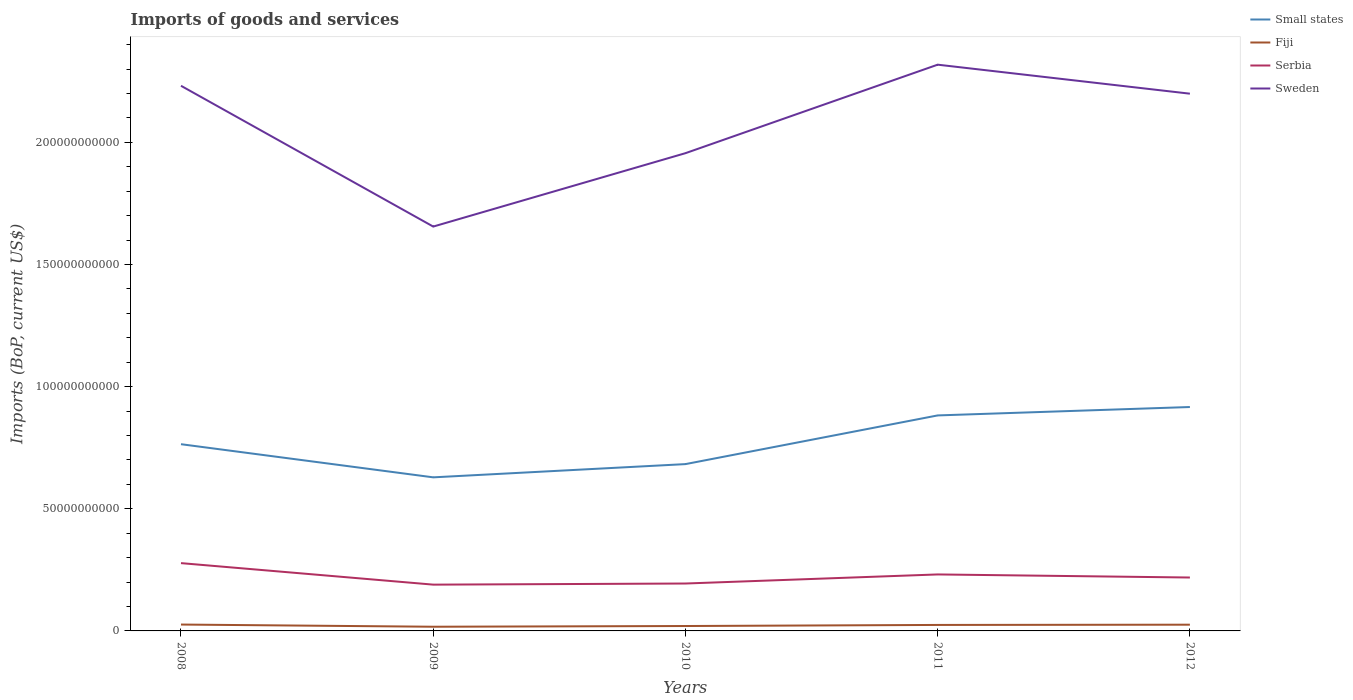How many different coloured lines are there?
Provide a short and direct response. 4. Is the number of lines equal to the number of legend labels?
Your answer should be very brief. Yes. Across all years, what is the maximum amount spent on imports in Sweden?
Make the answer very short. 1.66e+11. What is the total amount spent on imports in Serbia in the graph?
Offer a terse response. -2.46e+09. What is the difference between the highest and the second highest amount spent on imports in Sweden?
Your answer should be compact. 6.63e+1. Is the amount spent on imports in Serbia strictly greater than the amount spent on imports in Small states over the years?
Provide a succinct answer. Yes. How many years are there in the graph?
Keep it short and to the point. 5. What is the difference between two consecutive major ticks on the Y-axis?
Offer a very short reply. 5.00e+1. Are the values on the major ticks of Y-axis written in scientific E-notation?
Make the answer very short. No. Does the graph contain any zero values?
Provide a short and direct response. No. Where does the legend appear in the graph?
Provide a succinct answer. Top right. What is the title of the graph?
Your response must be concise. Imports of goods and services. Does "Lebanon" appear as one of the legend labels in the graph?
Give a very brief answer. No. What is the label or title of the X-axis?
Your answer should be very brief. Years. What is the label or title of the Y-axis?
Your answer should be compact. Imports (BoP, current US$). What is the Imports (BoP, current US$) in Small states in 2008?
Provide a short and direct response. 7.64e+1. What is the Imports (BoP, current US$) in Fiji in 2008?
Give a very brief answer. 2.61e+09. What is the Imports (BoP, current US$) in Serbia in 2008?
Provide a succinct answer. 2.78e+1. What is the Imports (BoP, current US$) of Sweden in 2008?
Keep it short and to the point. 2.23e+11. What is the Imports (BoP, current US$) of Small states in 2009?
Provide a succinct answer. 6.29e+1. What is the Imports (BoP, current US$) of Fiji in 2009?
Give a very brief answer. 1.71e+09. What is the Imports (BoP, current US$) in Serbia in 2009?
Keep it short and to the point. 1.89e+1. What is the Imports (BoP, current US$) of Sweden in 2009?
Offer a terse response. 1.66e+11. What is the Imports (BoP, current US$) of Small states in 2010?
Your answer should be compact. 6.83e+1. What is the Imports (BoP, current US$) in Fiji in 2010?
Keep it short and to the point. 2.01e+09. What is the Imports (BoP, current US$) in Serbia in 2010?
Your answer should be compact. 1.94e+1. What is the Imports (BoP, current US$) in Sweden in 2010?
Your answer should be compact. 1.96e+11. What is the Imports (BoP, current US$) of Small states in 2011?
Offer a very short reply. 8.82e+1. What is the Imports (BoP, current US$) in Fiji in 2011?
Offer a terse response. 2.45e+09. What is the Imports (BoP, current US$) in Serbia in 2011?
Offer a very short reply. 2.31e+1. What is the Imports (BoP, current US$) of Sweden in 2011?
Provide a short and direct response. 2.32e+11. What is the Imports (BoP, current US$) of Small states in 2012?
Your response must be concise. 9.17e+1. What is the Imports (BoP, current US$) in Fiji in 2012?
Provide a succinct answer. 2.55e+09. What is the Imports (BoP, current US$) in Serbia in 2012?
Your answer should be compact. 2.19e+1. What is the Imports (BoP, current US$) in Sweden in 2012?
Your answer should be compact. 2.20e+11. Across all years, what is the maximum Imports (BoP, current US$) of Small states?
Your response must be concise. 9.17e+1. Across all years, what is the maximum Imports (BoP, current US$) of Fiji?
Make the answer very short. 2.61e+09. Across all years, what is the maximum Imports (BoP, current US$) of Serbia?
Offer a very short reply. 2.78e+1. Across all years, what is the maximum Imports (BoP, current US$) in Sweden?
Give a very brief answer. 2.32e+11. Across all years, what is the minimum Imports (BoP, current US$) in Small states?
Keep it short and to the point. 6.29e+1. Across all years, what is the minimum Imports (BoP, current US$) of Fiji?
Your answer should be compact. 1.71e+09. Across all years, what is the minimum Imports (BoP, current US$) of Serbia?
Provide a succinct answer. 1.89e+1. Across all years, what is the minimum Imports (BoP, current US$) in Sweden?
Your answer should be very brief. 1.66e+11. What is the total Imports (BoP, current US$) of Small states in the graph?
Provide a succinct answer. 3.87e+11. What is the total Imports (BoP, current US$) in Fiji in the graph?
Give a very brief answer. 1.13e+1. What is the total Imports (BoP, current US$) of Serbia in the graph?
Ensure brevity in your answer.  1.11e+11. What is the total Imports (BoP, current US$) of Sweden in the graph?
Offer a terse response. 1.04e+12. What is the difference between the Imports (BoP, current US$) of Small states in 2008 and that in 2009?
Your response must be concise. 1.36e+1. What is the difference between the Imports (BoP, current US$) in Fiji in 2008 and that in 2009?
Provide a short and direct response. 8.98e+08. What is the difference between the Imports (BoP, current US$) of Serbia in 2008 and that in 2009?
Your answer should be very brief. 8.80e+09. What is the difference between the Imports (BoP, current US$) of Sweden in 2008 and that in 2009?
Offer a very short reply. 5.76e+1. What is the difference between the Imports (BoP, current US$) of Small states in 2008 and that in 2010?
Offer a terse response. 8.15e+09. What is the difference between the Imports (BoP, current US$) of Fiji in 2008 and that in 2010?
Offer a very short reply. 6.00e+08. What is the difference between the Imports (BoP, current US$) of Serbia in 2008 and that in 2010?
Provide a succinct answer. 8.35e+09. What is the difference between the Imports (BoP, current US$) of Sweden in 2008 and that in 2010?
Offer a terse response. 2.76e+1. What is the difference between the Imports (BoP, current US$) of Small states in 2008 and that in 2011?
Ensure brevity in your answer.  -1.18e+1. What is the difference between the Imports (BoP, current US$) in Fiji in 2008 and that in 2011?
Provide a short and direct response. 1.58e+08. What is the difference between the Imports (BoP, current US$) in Serbia in 2008 and that in 2011?
Provide a short and direct response. 4.63e+09. What is the difference between the Imports (BoP, current US$) of Sweden in 2008 and that in 2011?
Make the answer very short. -8.64e+09. What is the difference between the Imports (BoP, current US$) of Small states in 2008 and that in 2012?
Offer a terse response. -1.52e+1. What is the difference between the Imports (BoP, current US$) in Fiji in 2008 and that in 2012?
Ensure brevity in your answer.  5.92e+07. What is the difference between the Imports (BoP, current US$) in Serbia in 2008 and that in 2012?
Keep it short and to the point. 5.89e+09. What is the difference between the Imports (BoP, current US$) in Sweden in 2008 and that in 2012?
Make the answer very short. 3.24e+09. What is the difference between the Imports (BoP, current US$) of Small states in 2009 and that in 2010?
Give a very brief answer. -5.42e+09. What is the difference between the Imports (BoP, current US$) of Fiji in 2009 and that in 2010?
Offer a terse response. -2.98e+08. What is the difference between the Imports (BoP, current US$) of Serbia in 2009 and that in 2010?
Offer a very short reply. -4.57e+08. What is the difference between the Imports (BoP, current US$) of Sweden in 2009 and that in 2010?
Give a very brief answer. -3.00e+1. What is the difference between the Imports (BoP, current US$) of Small states in 2009 and that in 2011?
Your response must be concise. -2.53e+1. What is the difference between the Imports (BoP, current US$) in Fiji in 2009 and that in 2011?
Ensure brevity in your answer.  -7.40e+08. What is the difference between the Imports (BoP, current US$) in Serbia in 2009 and that in 2011?
Give a very brief answer. -4.17e+09. What is the difference between the Imports (BoP, current US$) in Sweden in 2009 and that in 2011?
Your response must be concise. -6.63e+1. What is the difference between the Imports (BoP, current US$) in Small states in 2009 and that in 2012?
Your answer should be compact. -2.88e+1. What is the difference between the Imports (BoP, current US$) in Fiji in 2009 and that in 2012?
Keep it short and to the point. -8.39e+08. What is the difference between the Imports (BoP, current US$) of Serbia in 2009 and that in 2012?
Give a very brief answer. -2.91e+09. What is the difference between the Imports (BoP, current US$) of Sweden in 2009 and that in 2012?
Ensure brevity in your answer.  -5.44e+1. What is the difference between the Imports (BoP, current US$) of Small states in 2010 and that in 2011?
Ensure brevity in your answer.  -1.99e+1. What is the difference between the Imports (BoP, current US$) in Fiji in 2010 and that in 2011?
Keep it short and to the point. -4.42e+08. What is the difference between the Imports (BoP, current US$) of Serbia in 2010 and that in 2011?
Your answer should be compact. -3.71e+09. What is the difference between the Imports (BoP, current US$) in Sweden in 2010 and that in 2011?
Offer a very short reply. -3.62e+1. What is the difference between the Imports (BoP, current US$) of Small states in 2010 and that in 2012?
Provide a short and direct response. -2.34e+1. What is the difference between the Imports (BoP, current US$) of Fiji in 2010 and that in 2012?
Your response must be concise. -5.41e+08. What is the difference between the Imports (BoP, current US$) of Serbia in 2010 and that in 2012?
Your answer should be compact. -2.46e+09. What is the difference between the Imports (BoP, current US$) of Sweden in 2010 and that in 2012?
Ensure brevity in your answer.  -2.44e+1. What is the difference between the Imports (BoP, current US$) of Small states in 2011 and that in 2012?
Provide a succinct answer. -3.44e+09. What is the difference between the Imports (BoP, current US$) of Fiji in 2011 and that in 2012?
Offer a very short reply. -9.92e+07. What is the difference between the Imports (BoP, current US$) of Serbia in 2011 and that in 2012?
Make the answer very short. 1.26e+09. What is the difference between the Imports (BoP, current US$) in Sweden in 2011 and that in 2012?
Give a very brief answer. 1.19e+1. What is the difference between the Imports (BoP, current US$) of Small states in 2008 and the Imports (BoP, current US$) of Fiji in 2009?
Your answer should be very brief. 7.47e+1. What is the difference between the Imports (BoP, current US$) of Small states in 2008 and the Imports (BoP, current US$) of Serbia in 2009?
Your answer should be very brief. 5.75e+1. What is the difference between the Imports (BoP, current US$) in Small states in 2008 and the Imports (BoP, current US$) in Sweden in 2009?
Your response must be concise. -8.91e+1. What is the difference between the Imports (BoP, current US$) in Fiji in 2008 and the Imports (BoP, current US$) in Serbia in 2009?
Provide a short and direct response. -1.63e+1. What is the difference between the Imports (BoP, current US$) in Fiji in 2008 and the Imports (BoP, current US$) in Sweden in 2009?
Ensure brevity in your answer.  -1.63e+11. What is the difference between the Imports (BoP, current US$) in Serbia in 2008 and the Imports (BoP, current US$) in Sweden in 2009?
Your answer should be compact. -1.38e+11. What is the difference between the Imports (BoP, current US$) in Small states in 2008 and the Imports (BoP, current US$) in Fiji in 2010?
Your answer should be compact. 7.44e+1. What is the difference between the Imports (BoP, current US$) in Small states in 2008 and the Imports (BoP, current US$) in Serbia in 2010?
Your answer should be very brief. 5.70e+1. What is the difference between the Imports (BoP, current US$) of Small states in 2008 and the Imports (BoP, current US$) of Sweden in 2010?
Provide a succinct answer. -1.19e+11. What is the difference between the Imports (BoP, current US$) in Fiji in 2008 and the Imports (BoP, current US$) in Serbia in 2010?
Provide a succinct answer. -1.68e+1. What is the difference between the Imports (BoP, current US$) of Fiji in 2008 and the Imports (BoP, current US$) of Sweden in 2010?
Your answer should be compact. -1.93e+11. What is the difference between the Imports (BoP, current US$) in Serbia in 2008 and the Imports (BoP, current US$) in Sweden in 2010?
Offer a terse response. -1.68e+11. What is the difference between the Imports (BoP, current US$) in Small states in 2008 and the Imports (BoP, current US$) in Fiji in 2011?
Provide a short and direct response. 7.40e+1. What is the difference between the Imports (BoP, current US$) in Small states in 2008 and the Imports (BoP, current US$) in Serbia in 2011?
Ensure brevity in your answer.  5.33e+1. What is the difference between the Imports (BoP, current US$) of Small states in 2008 and the Imports (BoP, current US$) of Sweden in 2011?
Offer a very short reply. -1.55e+11. What is the difference between the Imports (BoP, current US$) in Fiji in 2008 and the Imports (BoP, current US$) in Serbia in 2011?
Offer a terse response. -2.05e+1. What is the difference between the Imports (BoP, current US$) in Fiji in 2008 and the Imports (BoP, current US$) in Sweden in 2011?
Ensure brevity in your answer.  -2.29e+11. What is the difference between the Imports (BoP, current US$) in Serbia in 2008 and the Imports (BoP, current US$) in Sweden in 2011?
Keep it short and to the point. -2.04e+11. What is the difference between the Imports (BoP, current US$) in Small states in 2008 and the Imports (BoP, current US$) in Fiji in 2012?
Offer a very short reply. 7.39e+1. What is the difference between the Imports (BoP, current US$) of Small states in 2008 and the Imports (BoP, current US$) of Serbia in 2012?
Your answer should be very brief. 5.46e+1. What is the difference between the Imports (BoP, current US$) of Small states in 2008 and the Imports (BoP, current US$) of Sweden in 2012?
Offer a terse response. -1.43e+11. What is the difference between the Imports (BoP, current US$) in Fiji in 2008 and the Imports (BoP, current US$) in Serbia in 2012?
Offer a terse response. -1.93e+1. What is the difference between the Imports (BoP, current US$) of Fiji in 2008 and the Imports (BoP, current US$) of Sweden in 2012?
Provide a short and direct response. -2.17e+11. What is the difference between the Imports (BoP, current US$) of Serbia in 2008 and the Imports (BoP, current US$) of Sweden in 2012?
Give a very brief answer. -1.92e+11. What is the difference between the Imports (BoP, current US$) in Small states in 2009 and the Imports (BoP, current US$) in Fiji in 2010?
Offer a terse response. 6.09e+1. What is the difference between the Imports (BoP, current US$) of Small states in 2009 and the Imports (BoP, current US$) of Serbia in 2010?
Make the answer very short. 4.35e+1. What is the difference between the Imports (BoP, current US$) of Small states in 2009 and the Imports (BoP, current US$) of Sweden in 2010?
Offer a very short reply. -1.33e+11. What is the difference between the Imports (BoP, current US$) in Fiji in 2009 and the Imports (BoP, current US$) in Serbia in 2010?
Your response must be concise. -1.77e+1. What is the difference between the Imports (BoP, current US$) in Fiji in 2009 and the Imports (BoP, current US$) in Sweden in 2010?
Keep it short and to the point. -1.94e+11. What is the difference between the Imports (BoP, current US$) in Serbia in 2009 and the Imports (BoP, current US$) in Sweden in 2010?
Keep it short and to the point. -1.77e+11. What is the difference between the Imports (BoP, current US$) in Small states in 2009 and the Imports (BoP, current US$) in Fiji in 2011?
Offer a very short reply. 6.04e+1. What is the difference between the Imports (BoP, current US$) in Small states in 2009 and the Imports (BoP, current US$) in Serbia in 2011?
Ensure brevity in your answer.  3.97e+1. What is the difference between the Imports (BoP, current US$) of Small states in 2009 and the Imports (BoP, current US$) of Sweden in 2011?
Keep it short and to the point. -1.69e+11. What is the difference between the Imports (BoP, current US$) of Fiji in 2009 and the Imports (BoP, current US$) of Serbia in 2011?
Give a very brief answer. -2.14e+1. What is the difference between the Imports (BoP, current US$) of Fiji in 2009 and the Imports (BoP, current US$) of Sweden in 2011?
Your response must be concise. -2.30e+11. What is the difference between the Imports (BoP, current US$) of Serbia in 2009 and the Imports (BoP, current US$) of Sweden in 2011?
Make the answer very short. -2.13e+11. What is the difference between the Imports (BoP, current US$) of Small states in 2009 and the Imports (BoP, current US$) of Fiji in 2012?
Offer a very short reply. 6.03e+1. What is the difference between the Imports (BoP, current US$) of Small states in 2009 and the Imports (BoP, current US$) of Serbia in 2012?
Your response must be concise. 4.10e+1. What is the difference between the Imports (BoP, current US$) of Small states in 2009 and the Imports (BoP, current US$) of Sweden in 2012?
Your answer should be compact. -1.57e+11. What is the difference between the Imports (BoP, current US$) in Fiji in 2009 and the Imports (BoP, current US$) in Serbia in 2012?
Keep it short and to the point. -2.01e+1. What is the difference between the Imports (BoP, current US$) in Fiji in 2009 and the Imports (BoP, current US$) in Sweden in 2012?
Make the answer very short. -2.18e+11. What is the difference between the Imports (BoP, current US$) of Serbia in 2009 and the Imports (BoP, current US$) of Sweden in 2012?
Provide a succinct answer. -2.01e+11. What is the difference between the Imports (BoP, current US$) in Small states in 2010 and the Imports (BoP, current US$) in Fiji in 2011?
Make the answer very short. 6.58e+1. What is the difference between the Imports (BoP, current US$) in Small states in 2010 and the Imports (BoP, current US$) in Serbia in 2011?
Offer a very short reply. 4.52e+1. What is the difference between the Imports (BoP, current US$) of Small states in 2010 and the Imports (BoP, current US$) of Sweden in 2011?
Make the answer very short. -1.64e+11. What is the difference between the Imports (BoP, current US$) of Fiji in 2010 and the Imports (BoP, current US$) of Serbia in 2011?
Provide a succinct answer. -2.11e+1. What is the difference between the Imports (BoP, current US$) of Fiji in 2010 and the Imports (BoP, current US$) of Sweden in 2011?
Keep it short and to the point. -2.30e+11. What is the difference between the Imports (BoP, current US$) of Serbia in 2010 and the Imports (BoP, current US$) of Sweden in 2011?
Your answer should be very brief. -2.12e+11. What is the difference between the Imports (BoP, current US$) in Small states in 2010 and the Imports (BoP, current US$) in Fiji in 2012?
Offer a terse response. 6.57e+1. What is the difference between the Imports (BoP, current US$) of Small states in 2010 and the Imports (BoP, current US$) of Serbia in 2012?
Offer a very short reply. 4.64e+1. What is the difference between the Imports (BoP, current US$) in Small states in 2010 and the Imports (BoP, current US$) in Sweden in 2012?
Provide a succinct answer. -1.52e+11. What is the difference between the Imports (BoP, current US$) in Fiji in 2010 and the Imports (BoP, current US$) in Serbia in 2012?
Keep it short and to the point. -1.99e+1. What is the difference between the Imports (BoP, current US$) of Fiji in 2010 and the Imports (BoP, current US$) of Sweden in 2012?
Your answer should be compact. -2.18e+11. What is the difference between the Imports (BoP, current US$) in Serbia in 2010 and the Imports (BoP, current US$) in Sweden in 2012?
Ensure brevity in your answer.  -2.01e+11. What is the difference between the Imports (BoP, current US$) in Small states in 2011 and the Imports (BoP, current US$) in Fiji in 2012?
Your response must be concise. 8.57e+1. What is the difference between the Imports (BoP, current US$) of Small states in 2011 and the Imports (BoP, current US$) of Serbia in 2012?
Give a very brief answer. 6.64e+1. What is the difference between the Imports (BoP, current US$) of Small states in 2011 and the Imports (BoP, current US$) of Sweden in 2012?
Keep it short and to the point. -1.32e+11. What is the difference between the Imports (BoP, current US$) in Fiji in 2011 and the Imports (BoP, current US$) in Serbia in 2012?
Keep it short and to the point. -1.94e+1. What is the difference between the Imports (BoP, current US$) in Fiji in 2011 and the Imports (BoP, current US$) in Sweden in 2012?
Provide a succinct answer. -2.17e+11. What is the difference between the Imports (BoP, current US$) of Serbia in 2011 and the Imports (BoP, current US$) of Sweden in 2012?
Keep it short and to the point. -1.97e+11. What is the average Imports (BoP, current US$) of Small states per year?
Your response must be concise. 7.75e+1. What is the average Imports (BoP, current US$) in Fiji per year?
Your answer should be compact. 2.27e+09. What is the average Imports (BoP, current US$) of Serbia per year?
Provide a short and direct response. 2.22e+1. What is the average Imports (BoP, current US$) in Sweden per year?
Provide a short and direct response. 2.07e+11. In the year 2008, what is the difference between the Imports (BoP, current US$) in Small states and Imports (BoP, current US$) in Fiji?
Give a very brief answer. 7.38e+1. In the year 2008, what is the difference between the Imports (BoP, current US$) of Small states and Imports (BoP, current US$) of Serbia?
Make the answer very short. 4.87e+1. In the year 2008, what is the difference between the Imports (BoP, current US$) of Small states and Imports (BoP, current US$) of Sweden?
Your answer should be compact. -1.47e+11. In the year 2008, what is the difference between the Imports (BoP, current US$) in Fiji and Imports (BoP, current US$) in Serbia?
Offer a terse response. -2.51e+1. In the year 2008, what is the difference between the Imports (BoP, current US$) in Fiji and Imports (BoP, current US$) in Sweden?
Give a very brief answer. -2.21e+11. In the year 2008, what is the difference between the Imports (BoP, current US$) in Serbia and Imports (BoP, current US$) in Sweden?
Provide a short and direct response. -1.95e+11. In the year 2009, what is the difference between the Imports (BoP, current US$) of Small states and Imports (BoP, current US$) of Fiji?
Offer a very short reply. 6.12e+1. In the year 2009, what is the difference between the Imports (BoP, current US$) of Small states and Imports (BoP, current US$) of Serbia?
Give a very brief answer. 4.39e+1. In the year 2009, what is the difference between the Imports (BoP, current US$) of Small states and Imports (BoP, current US$) of Sweden?
Keep it short and to the point. -1.03e+11. In the year 2009, what is the difference between the Imports (BoP, current US$) of Fiji and Imports (BoP, current US$) of Serbia?
Your answer should be compact. -1.72e+1. In the year 2009, what is the difference between the Imports (BoP, current US$) of Fiji and Imports (BoP, current US$) of Sweden?
Give a very brief answer. -1.64e+11. In the year 2009, what is the difference between the Imports (BoP, current US$) of Serbia and Imports (BoP, current US$) of Sweden?
Provide a succinct answer. -1.47e+11. In the year 2010, what is the difference between the Imports (BoP, current US$) in Small states and Imports (BoP, current US$) in Fiji?
Your answer should be very brief. 6.63e+1. In the year 2010, what is the difference between the Imports (BoP, current US$) of Small states and Imports (BoP, current US$) of Serbia?
Your response must be concise. 4.89e+1. In the year 2010, what is the difference between the Imports (BoP, current US$) in Small states and Imports (BoP, current US$) in Sweden?
Keep it short and to the point. -1.27e+11. In the year 2010, what is the difference between the Imports (BoP, current US$) of Fiji and Imports (BoP, current US$) of Serbia?
Offer a very short reply. -1.74e+1. In the year 2010, what is the difference between the Imports (BoP, current US$) in Fiji and Imports (BoP, current US$) in Sweden?
Offer a terse response. -1.94e+11. In the year 2010, what is the difference between the Imports (BoP, current US$) in Serbia and Imports (BoP, current US$) in Sweden?
Offer a terse response. -1.76e+11. In the year 2011, what is the difference between the Imports (BoP, current US$) in Small states and Imports (BoP, current US$) in Fiji?
Provide a short and direct response. 8.58e+1. In the year 2011, what is the difference between the Imports (BoP, current US$) of Small states and Imports (BoP, current US$) of Serbia?
Offer a very short reply. 6.51e+1. In the year 2011, what is the difference between the Imports (BoP, current US$) of Small states and Imports (BoP, current US$) of Sweden?
Offer a terse response. -1.44e+11. In the year 2011, what is the difference between the Imports (BoP, current US$) of Fiji and Imports (BoP, current US$) of Serbia?
Your response must be concise. -2.07e+1. In the year 2011, what is the difference between the Imports (BoP, current US$) in Fiji and Imports (BoP, current US$) in Sweden?
Give a very brief answer. -2.29e+11. In the year 2011, what is the difference between the Imports (BoP, current US$) in Serbia and Imports (BoP, current US$) in Sweden?
Ensure brevity in your answer.  -2.09e+11. In the year 2012, what is the difference between the Imports (BoP, current US$) of Small states and Imports (BoP, current US$) of Fiji?
Your answer should be compact. 8.91e+1. In the year 2012, what is the difference between the Imports (BoP, current US$) of Small states and Imports (BoP, current US$) of Serbia?
Offer a terse response. 6.98e+1. In the year 2012, what is the difference between the Imports (BoP, current US$) in Small states and Imports (BoP, current US$) in Sweden?
Keep it short and to the point. -1.28e+11. In the year 2012, what is the difference between the Imports (BoP, current US$) of Fiji and Imports (BoP, current US$) of Serbia?
Give a very brief answer. -1.93e+1. In the year 2012, what is the difference between the Imports (BoP, current US$) in Fiji and Imports (BoP, current US$) in Sweden?
Your response must be concise. -2.17e+11. In the year 2012, what is the difference between the Imports (BoP, current US$) in Serbia and Imports (BoP, current US$) in Sweden?
Make the answer very short. -1.98e+11. What is the ratio of the Imports (BoP, current US$) in Small states in 2008 to that in 2009?
Your response must be concise. 1.22. What is the ratio of the Imports (BoP, current US$) of Fiji in 2008 to that in 2009?
Offer a very short reply. 1.52. What is the ratio of the Imports (BoP, current US$) of Serbia in 2008 to that in 2009?
Ensure brevity in your answer.  1.46. What is the ratio of the Imports (BoP, current US$) of Sweden in 2008 to that in 2009?
Provide a succinct answer. 1.35. What is the ratio of the Imports (BoP, current US$) in Small states in 2008 to that in 2010?
Your response must be concise. 1.12. What is the ratio of the Imports (BoP, current US$) in Fiji in 2008 to that in 2010?
Ensure brevity in your answer.  1.3. What is the ratio of the Imports (BoP, current US$) of Serbia in 2008 to that in 2010?
Make the answer very short. 1.43. What is the ratio of the Imports (BoP, current US$) in Sweden in 2008 to that in 2010?
Provide a succinct answer. 1.14. What is the ratio of the Imports (BoP, current US$) of Small states in 2008 to that in 2011?
Offer a terse response. 0.87. What is the ratio of the Imports (BoP, current US$) of Fiji in 2008 to that in 2011?
Your response must be concise. 1.06. What is the ratio of the Imports (BoP, current US$) of Serbia in 2008 to that in 2011?
Your answer should be very brief. 1.2. What is the ratio of the Imports (BoP, current US$) of Sweden in 2008 to that in 2011?
Your answer should be compact. 0.96. What is the ratio of the Imports (BoP, current US$) of Small states in 2008 to that in 2012?
Keep it short and to the point. 0.83. What is the ratio of the Imports (BoP, current US$) of Fiji in 2008 to that in 2012?
Make the answer very short. 1.02. What is the ratio of the Imports (BoP, current US$) of Serbia in 2008 to that in 2012?
Provide a short and direct response. 1.27. What is the ratio of the Imports (BoP, current US$) of Sweden in 2008 to that in 2012?
Your answer should be compact. 1.01. What is the ratio of the Imports (BoP, current US$) of Small states in 2009 to that in 2010?
Make the answer very short. 0.92. What is the ratio of the Imports (BoP, current US$) in Fiji in 2009 to that in 2010?
Ensure brevity in your answer.  0.85. What is the ratio of the Imports (BoP, current US$) of Serbia in 2009 to that in 2010?
Give a very brief answer. 0.98. What is the ratio of the Imports (BoP, current US$) in Sweden in 2009 to that in 2010?
Your response must be concise. 0.85. What is the ratio of the Imports (BoP, current US$) in Small states in 2009 to that in 2011?
Make the answer very short. 0.71. What is the ratio of the Imports (BoP, current US$) of Fiji in 2009 to that in 2011?
Your response must be concise. 0.7. What is the ratio of the Imports (BoP, current US$) in Serbia in 2009 to that in 2011?
Ensure brevity in your answer.  0.82. What is the ratio of the Imports (BoP, current US$) of Sweden in 2009 to that in 2011?
Keep it short and to the point. 0.71. What is the ratio of the Imports (BoP, current US$) of Small states in 2009 to that in 2012?
Make the answer very short. 0.69. What is the ratio of the Imports (BoP, current US$) of Fiji in 2009 to that in 2012?
Your answer should be very brief. 0.67. What is the ratio of the Imports (BoP, current US$) of Serbia in 2009 to that in 2012?
Provide a short and direct response. 0.87. What is the ratio of the Imports (BoP, current US$) of Sweden in 2009 to that in 2012?
Your answer should be very brief. 0.75. What is the ratio of the Imports (BoP, current US$) of Small states in 2010 to that in 2011?
Ensure brevity in your answer.  0.77. What is the ratio of the Imports (BoP, current US$) in Fiji in 2010 to that in 2011?
Offer a terse response. 0.82. What is the ratio of the Imports (BoP, current US$) in Serbia in 2010 to that in 2011?
Your response must be concise. 0.84. What is the ratio of the Imports (BoP, current US$) in Sweden in 2010 to that in 2011?
Give a very brief answer. 0.84. What is the ratio of the Imports (BoP, current US$) of Small states in 2010 to that in 2012?
Provide a short and direct response. 0.75. What is the ratio of the Imports (BoP, current US$) of Fiji in 2010 to that in 2012?
Your answer should be very brief. 0.79. What is the ratio of the Imports (BoP, current US$) of Serbia in 2010 to that in 2012?
Your answer should be compact. 0.89. What is the ratio of the Imports (BoP, current US$) in Sweden in 2010 to that in 2012?
Make the answer very short. 0.89. What is the ratio of the Imports (BoP, current US$) of Small states in 2011 to that in 2012?
Offer a terse response. 0.96. What is the ratio of the Imports (BoP, current US$) of Fiji in 2011 to that in 2012?
Give a very brief answer. 0.96. What is the ratio of the Imports (BoP, current US$) in Serbia in 2011 to that in 2012?
Provide a succinct answer. 1.06. What is the ratio of the Imports (BoP, current US$) in Sweden in 2011 to that in 2012?
Make the answer very short. 1.05. What is the difference between the highest and the second highest Imports (BoP, current US$) in Small states?
Give a very brief answer. 3.44e+09. What is the difference between the highest and the second highest Imports (BoP, current US$) of Fiji?
Provide a succinct answer. 5.92e+07. What is the difference between the highest and the second highest Imports (BoP, current US$) of Serbia?
Offer a very short reply. 4.63e+09. What is the difference between the highest and the second highest Imports (BoP, current US$) in Sweden?
Give a very brief answer. 8.64e+09. What is the difference between the highest and the lowest Imports (BoP, current US$) in Small states?
Your response must be concise. 2.88e+1. What is the difference between the highest and the lowest Imports (BoP, current US$) of Fiji?
Make the answer very short. 8.98e+08. What is the difference between the highest and the lowest Imports (BoP, current US$) in Serbia?
Your response must be concise. 8.80e+09. What is the difference between the highest and the lowest Imports (BoP, current US$) of Sweden?
Offer a very short reply. 6.63e+1. 